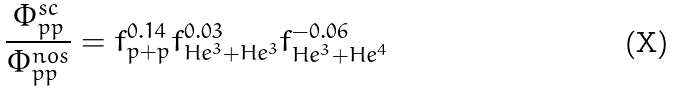<formula> <loc_0><loc_0><loc_500><loc_500>\frac { \Phi _ { p p } ^ { s c } } { \Phi _ { p p } ^ { n o s } } = f _ { p + p } ^ { 0 . 1 4 } f _ { H e ^ { 3 } + H e ^ { 3 } } ^ { 0 . 0 3 } f _ { H e ^ { 3 } + H e ^ { 4 } } ^ { - 0 . 0 6 }</formula> 